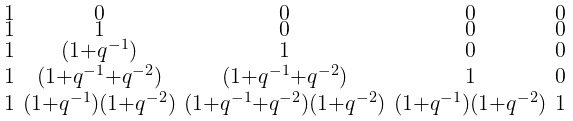<formula> <loc_0><loc_0><loc_500><loc_500>\begin{smallmatrix} 1 & 0 & 0 & 0 & 0 \\ 1 & 1 & 0 & 0 & 0 \\ 1 & ( 1 + q ^ { - 1 } ) & 1 & 0 & 0 \\ 1 & ( 1 + q ^ { - 1 } + q ^ { - 2 } ) & ( 1 + q ^ { - 1 } + q ^ { - 2 } ) & 1 & 0 \\ 1 & ( 1 + q ^ { - 1 } ) ( 1 + q ^ { - 2 } ) & ( 1 + q ^ { - 1 } + q ^ { - 2 } ) ( 1 + q ^ { - 2 } ) & ( 1 + q ^ { - 1 } ) ( 1 + q ^ { - 2 } ) & 1 \end{smallmatrix}</formula> 